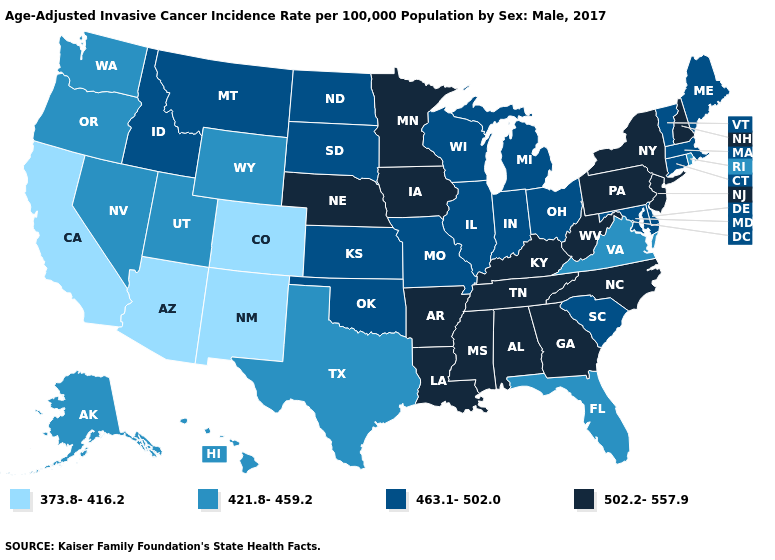Name the states that have a value in the range 421.8-459.2?
Write a very short answer. Alaska, Florida, Hawaii, Nevada, Oregon, Rhode Island, Texas, Utah, Virginia, Washington, Wyoming. Among the states that border Texas , does New Mexico have the lowest value?
Quick response, please. Yes. Name the states that have a value in the range 373.8-416.2?
Keep it brief. Arizona, California, Colorado, New Mexico. Which states have the highest value in the USA?
Short answer required. Alabama, Arkansas, Georgia, Iowa, Kentucky, Louisiana, Minnesota, Mississippi, Nebraska, New Hampshire, New Jersey, New York, North Carolina, Pennsylvania, Tennessee, West Virginia. What is the value of Ohio?
Quick response, please. 463.1-502.0. Name the states that have a value in the range 502.2-557.9?
Answer briefly. Alabama, Arkansas, Georgia, Iowa, Kentucky, Louisiana, Minnesota, Mississippi, Nebraska, New Hampshire, New Jersey, New York, North Carolina, Pennsylvania, Tennessee, West Virginia. What is the value of Rhode Island?
Quick response, please. 421.8-459.2. How many symbols are there in the legend?
Concise answer only. 4. Does the first symbol in the legend represent the smallest category?
Short answer required. Yes. Does New Hampshire have the lowest value in the USA?
Quick response, please. No. What is the highest value in the USA?
Be succinct. 502.2-557.9. Does the first symbol in the legend represent the smallest category?
Keep it brief. Yes. Which states have the highest value in the USA?
Be succinct. Alabama, Arkansas, Georgia, Iowa, Kentucky, Louisiana, Minnesota, Mississippi, Nebraska, New Hampshire, New Jersey, New York, North Carolina, Pennsylvania, Tennessee, West Virginia. Name the states that have a value in the range 421.8-459.2?
Quick response, please. Alaska, Florida, Hawaii, Nevada, Oregon, Rhode Island, Texas, Utah, Virginia, Washington, Wyoming. Does the first symbol in the legend represent the smallest category?
Be succinct. Yes. 